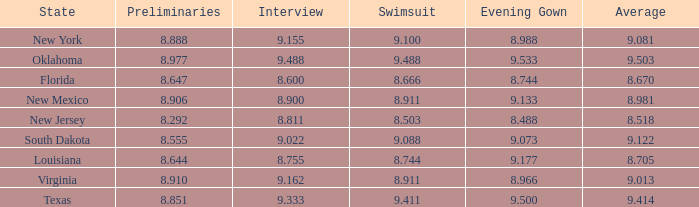What is the total number of average where evening gown is 8.988 1.0. 